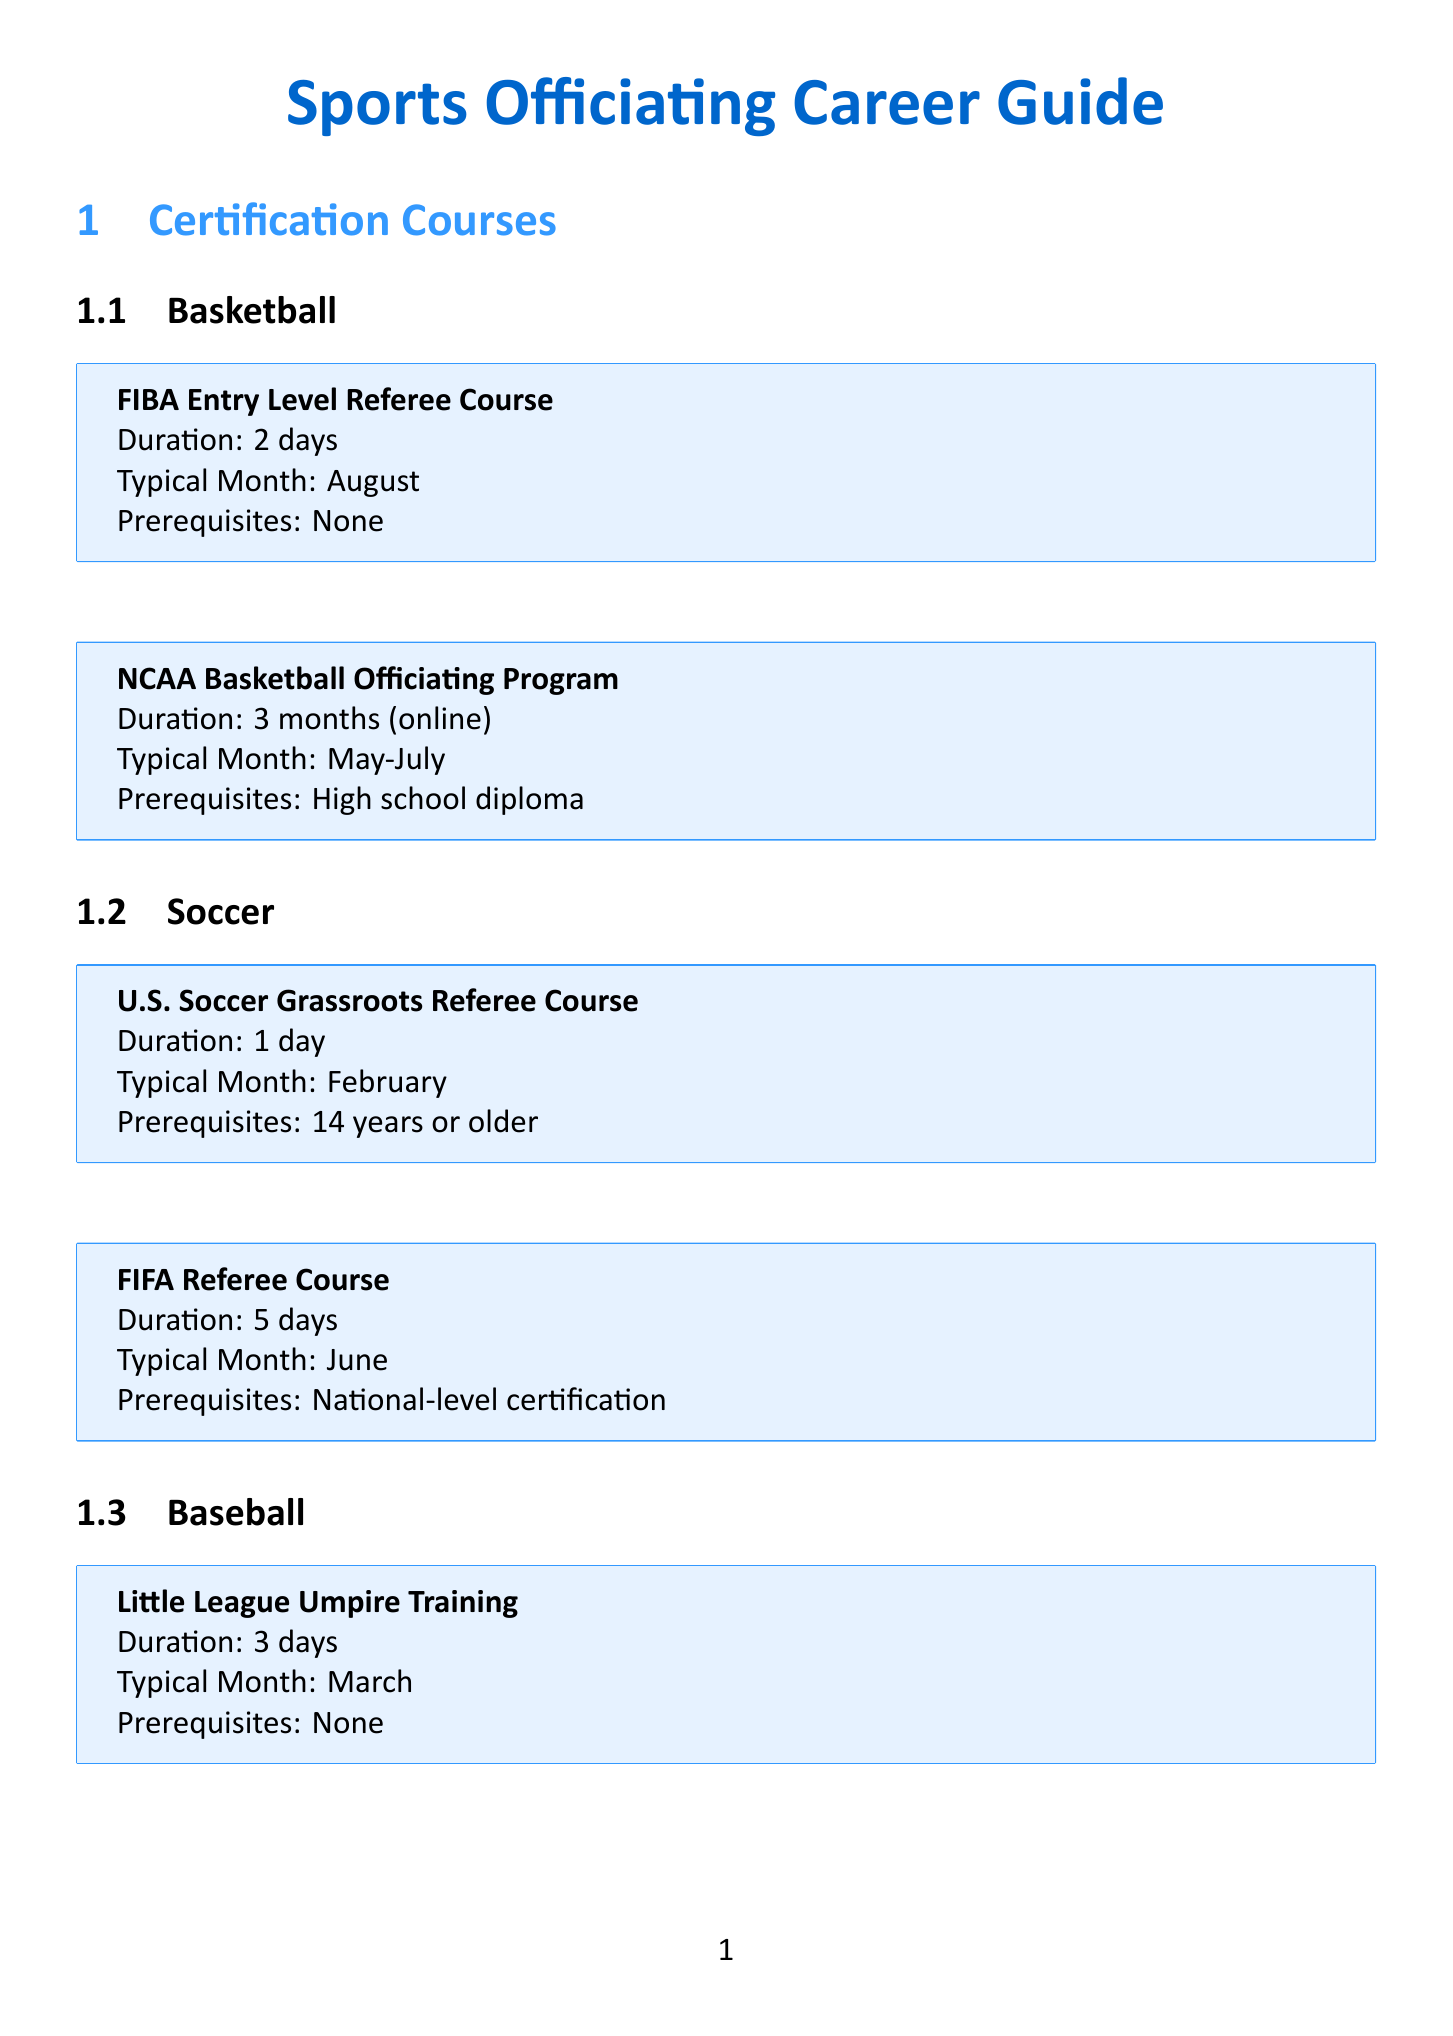what is the duration of the FIBA Entry Level Referee Course? The document states that the FIBA Entry Level Referee Course has a duration of 2 days.
Answer: 2 days when does the U.S. Soccer Grassroots Referee Course typically occur? The typical month for the U.S. Soccer Grassroots Referee Course is February according to the document.
Answer: February which exam has a passing score of 85%? The NBA G League Officials Exam requires a passing score of 85%, as mentioned in the document.
Answer: NBA G League Officials Exam how long is the MLB Umpire Camp? The document specifies that the MLB Umpire Camp lasts for 4 weeks.
Answer: 4 weeks what is the application deadline for the AYSO Youth Referee Mentor Program? The document indicates that the application deadline for the AYSO Youth Referee Mentor Program is March 15th.
Answer: March 15th which sport has a course that requires a high school diploma? The document shows that the NCAA Basketball Officiating Program has a prerequisite of a high school diploma.
Answer: Basketball how long is the Sports Officiating Summit? The Sports Officiating Summit has a duration of 3 days according to the document.
Answer: 3 days what is the format of the USSF Grade 8 Referee Exam? The document outlines that the USSF Grade 8 Referee Exam is in an online multiple-choice format.
Answer: Online multiple-choice in which month is the Rules Interpretation Clinic typically held? The document states that the Rules Interpretation Clinic is typically held in September.
Answer: September 